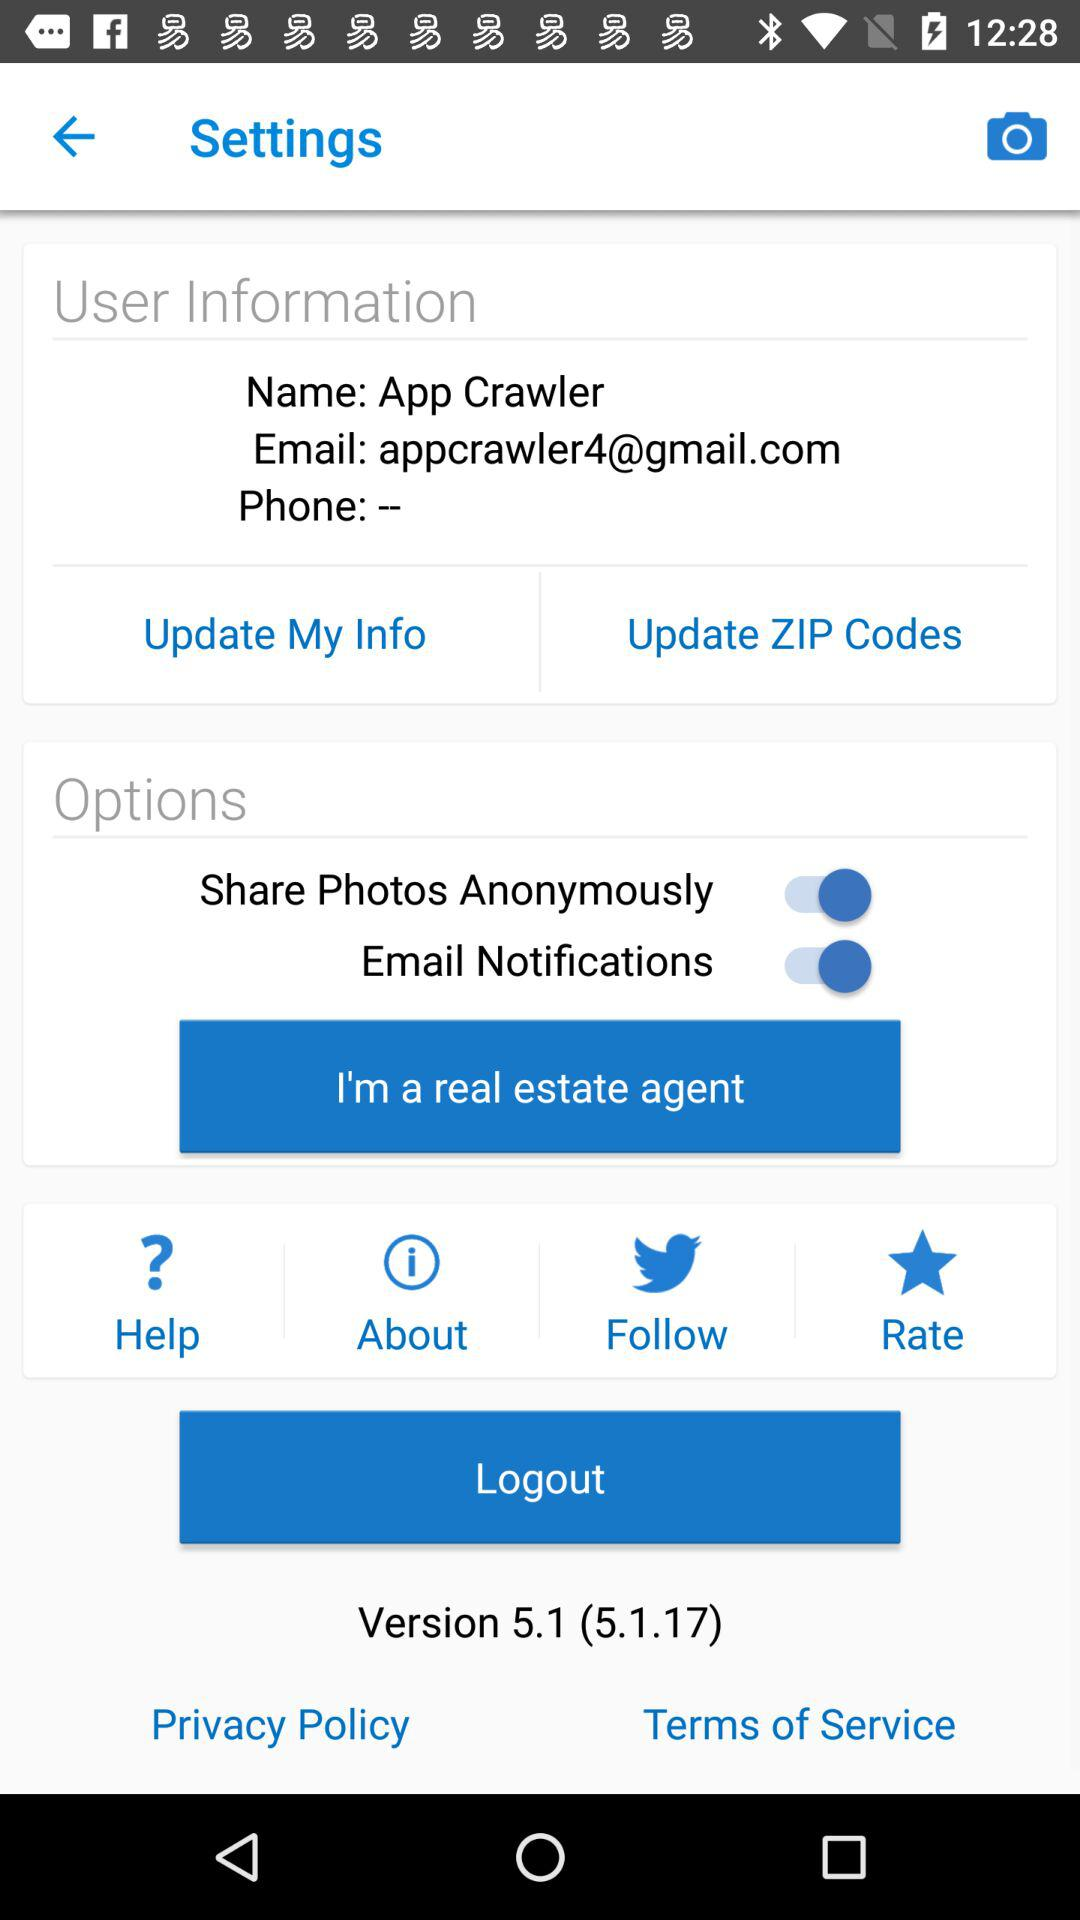What is the status of the "Share Photos Anonymously" setting? The status of the "Share Photos Anonymously" setting is "on". 